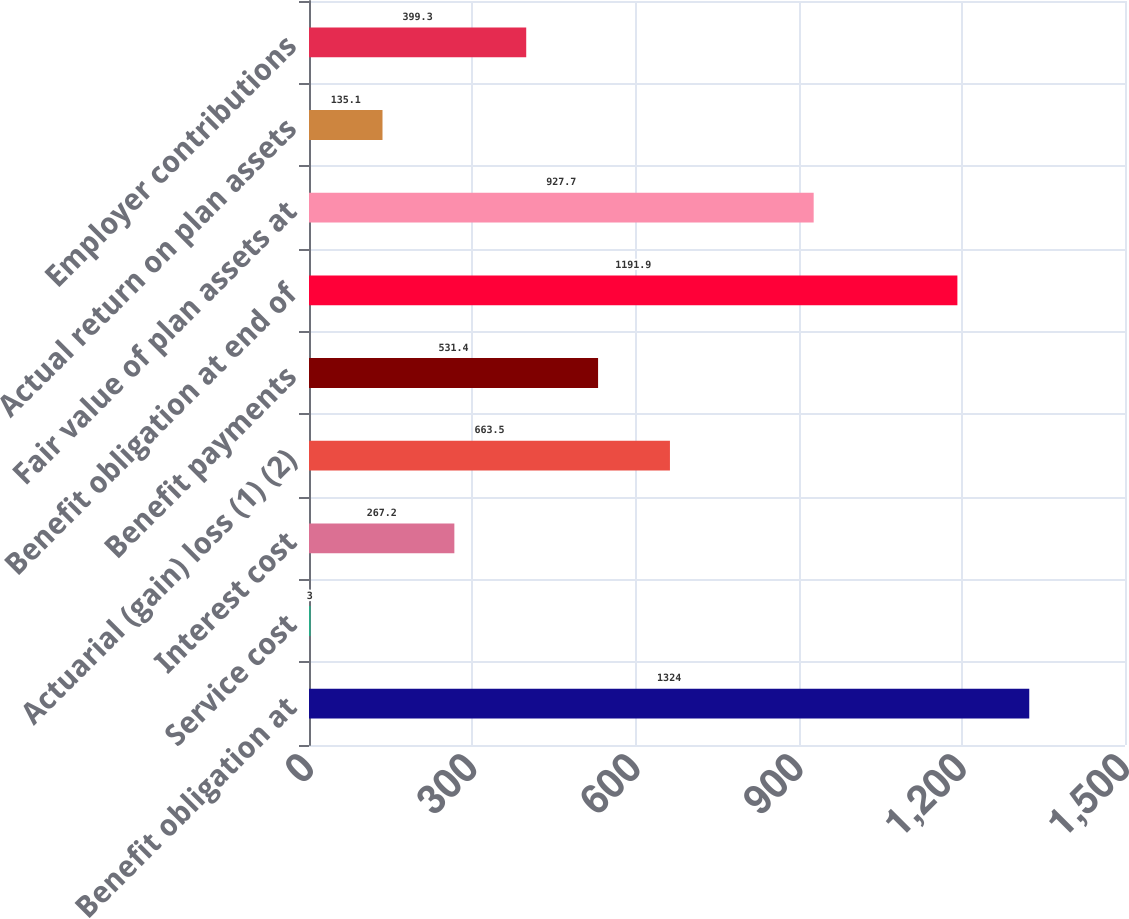Convert chart to OTSL. <chart><loc_0><loc_0><loc_500><loc_500><bar_chart><fcel>Benefit obligation at<fcel>Service cost<fcel>Interest cost<fcel>Actuarial (gain) loss (1) (2)<fcel>Benefit payments<fcel>Benefit obligation at end of<fcel>Fair value of plan assets at<fcel>Actual return on plan assets<fcel>Employer contributions<nl><fcel>1324<fcel>3<fcel>267.2<fcel>663.5<fcel>531.4<fcel>1191.9<fcel>927.7<fcel>135.1<fcel>399.3<nl></chart> 